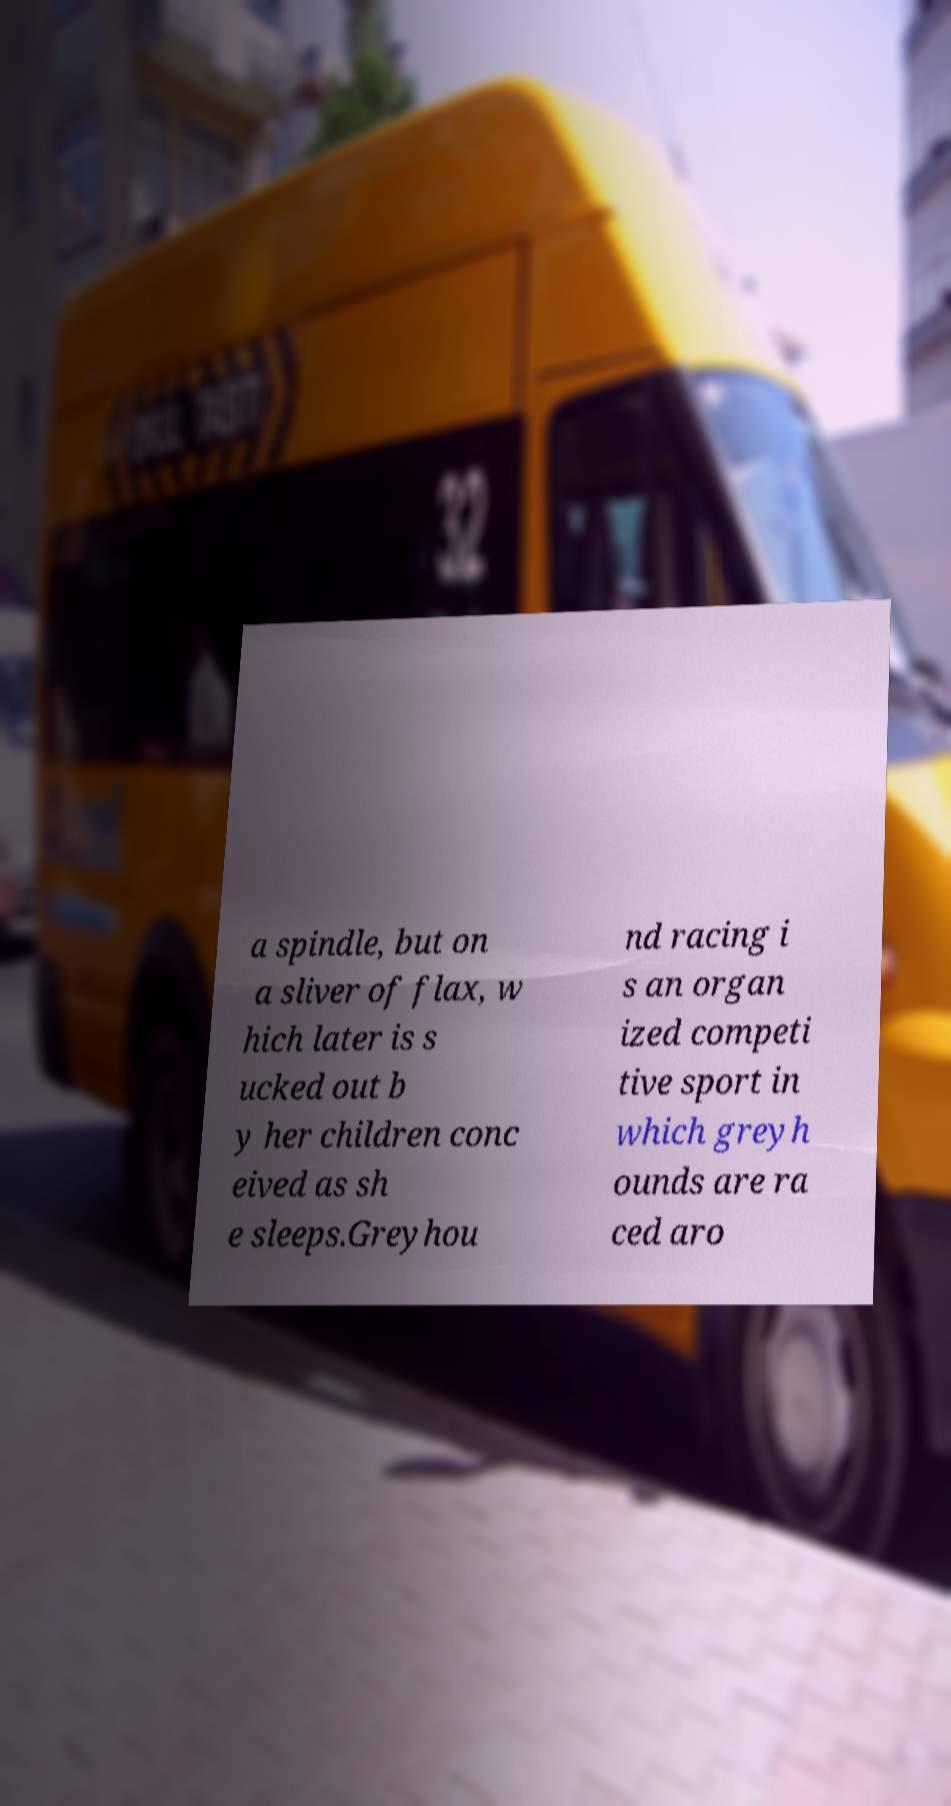Can you accurately transcribe the text from the provided image for me? a spindle, but on a sliver of flax, w hich later is s ucked out b y her children conc eived as sh e sleeps.Greyhou nd racing i s an organ ized competi tive sport in which greyh ounds are ra ced aro 